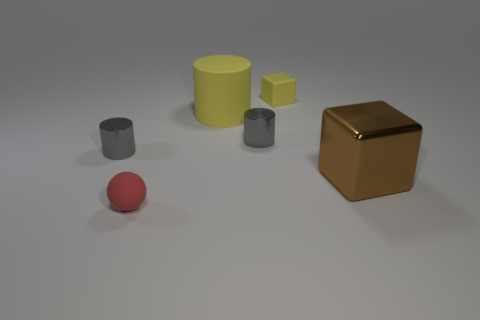Is there a big blue cylinder?
Provide a succinct answer. No. There is a tiny red thing; is it the same shape as the big thing left of the large brown shiny cube?
Your answer should be compact. No. What is the material of the cylinder that is behind the gray cylinder right of the sphere?
Ensure brevity in your answer.  Rubber. What is the color of the small matte ball?
Your answer should be compact. Red. There is a tiny matte object that is in front of the brown shiny object; is it the same color as the big object on the left side of the small rubber block?
Ensure brevity in your answer.  No. The yellow matte thing that is the same shape as the big brown object is what size?
Your response must be concise. Small. Are there any large shiny cylinders that have the same color as the ball?
Give a very brief answer. No. What is the material of the cylinder that is the same color as the matte block?
Your response must be concise. Rubber. How many rubber things have the same color as the rubber cylinder?
Give a very brief answer. 1. How many things are metallic objects that are to the left of the brown cube or large blocks?
Provide a succinct answer. 3. 